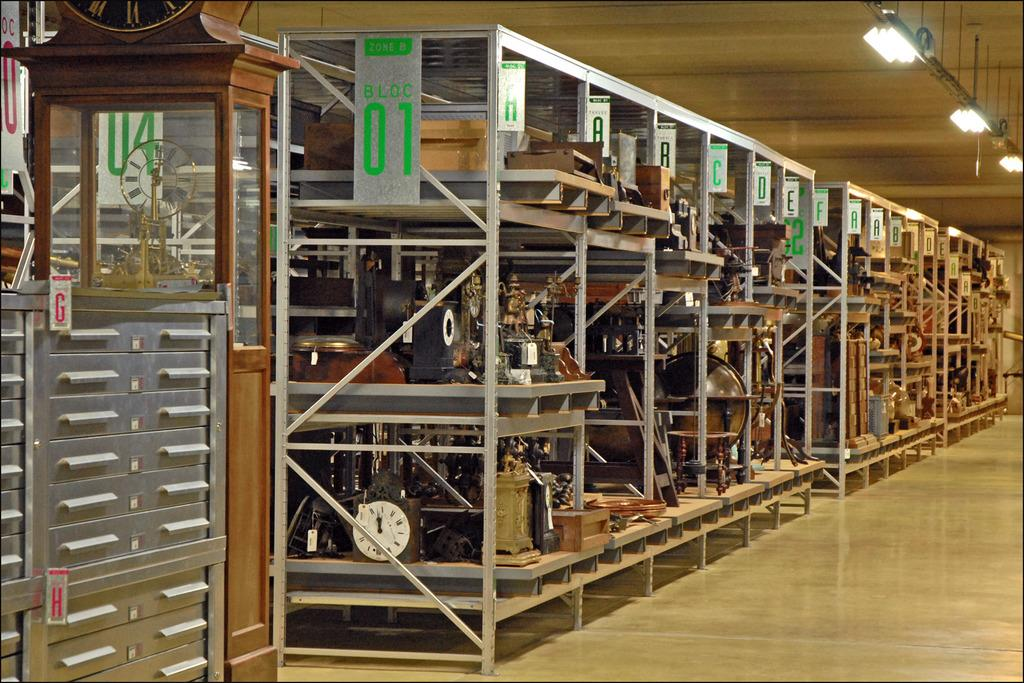<image>
Provide a brief description of the given image. empty antique store with a sign that says Block 01. 